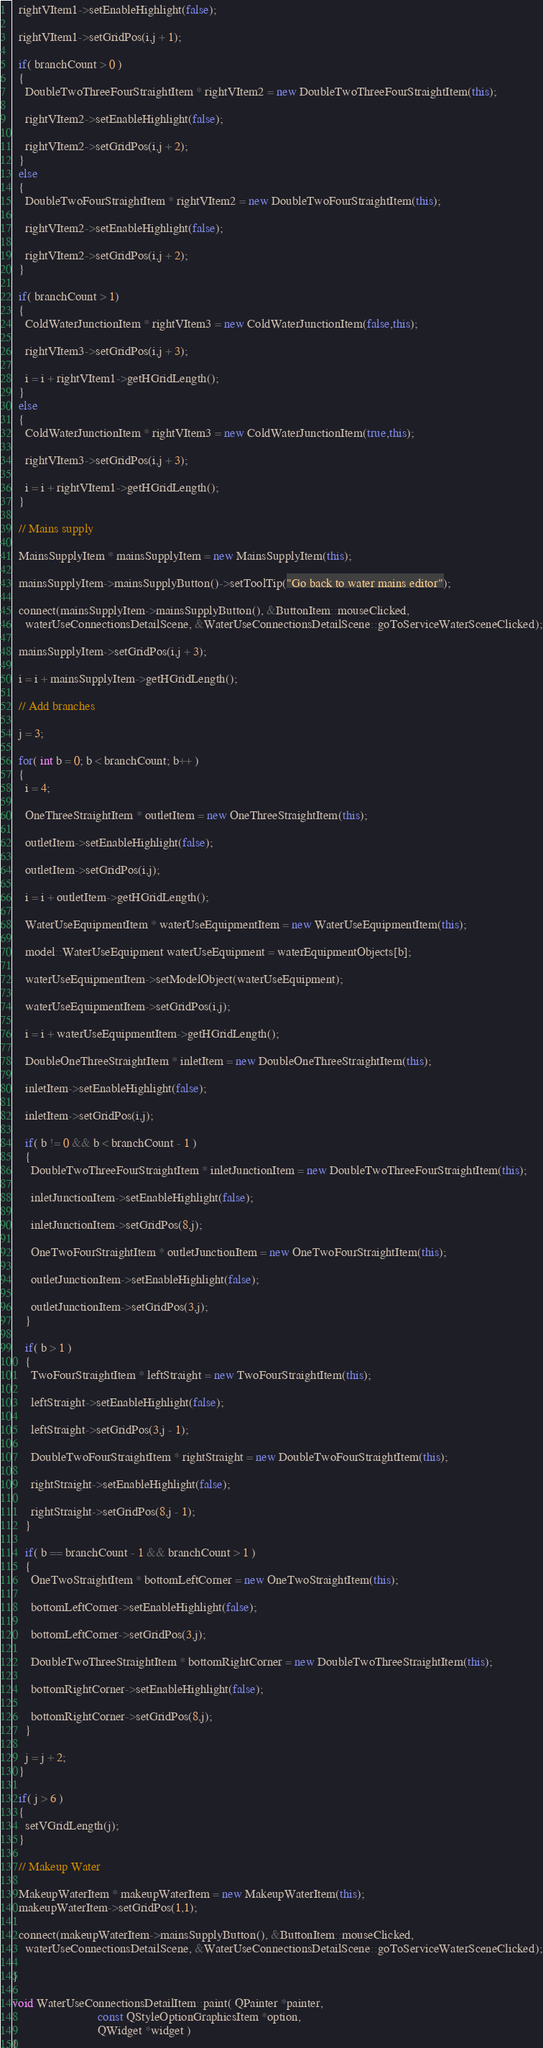<code> <loc_0><loc_0><loc_500><loc_500><_C++_>  rightVItem1->setEnableHighlight(false);

  rightVItem1->setGridPos(i,j + 1);

  if( branchCount > 0 )
  {
    DoubleTwoThreeFourStraightItem * rightVItem2 = new DoubleTwoThreeFourStraightItem(this);

    rightVItem2->setEnableHighlight(false);

    rightVItem2->setGridPos(i,j + 2);
  }
  else
  {
    DoubleTwoFourStraightItem * rightVItem2 = new DoubleTwoFourStraightItem(this);

    rightVItem2->setEnableHighlight(false);

    rightVItem2->setGridPos(i,j + 2);
  }

  if( branchCount > 1)
  {
    ColdWaterJunctionItem * rightVItem3 = new ColdWaterJunctionItem(false,this);

    rightVItem3->setGridPos(i,j + 3);

    i = i + rightVItem1->getHGridLength();
  }
  else
  {
    ColdWaterJunctionItem * rightVItem3 = new ColdWaterJunctionItem(true,this);

    rightVItem3->setGridPos(i,j + 3);

    i = i + rightVItem1->getHGridLength();
  }

  // Mains supply

  MainsSupplyItem * mainsSupplyItem = new MainsSupplyItem(this);

  mainsSupplyItem->mainsSupplyButton()->setToolTip("Go back to water mains editor");

  connect(mainsSupplyItem->mainsSupplyButton(), &ButtonItem::mouseClicked,
    waterUseConnectionsDetailScene, &WaterUseConnectionsDetailScene::goToServiceWaterSceneClicked);

  mainsSupplyItem->setGridPos(i,j + 3);

  i = i + mainsSupplyItem->getHGridLength();

  // Add branches

  j = 3;

  for( int b = 0; b < branchCount; b++ )
  {
    i = 4; 

    OneThreeStraightItem * outletItem = new OneThreeStraightItem(this);

    outletItem->setEnableHighlight(false);

    outletItem->setGridPos(i,j);

    i = i + outletItem->getHGridLength();

    WaterUseEquipmentItem * waterUseEquipmentItem = new WaterUseEquipmentItem(this);

    model::WaterUseEquipment waterUseEquipment = waterEquipmentObjects[b];

    waterUseEquipmentItem->setModelObject(waterUseEquipment);

    waterUseEquipmentItem->setGridPos(i,j);

    i = i + waterUseEquipmentItem->getHGridLength();

    DoubleOneThreeStraightItem * inletItem = new DoubleOneThreeStraightItem(this);

    inletItem->setEnableHighlight(false);

    inletItem->setGridPos(i,j);

    if( b != 0 && b < branchCount - 1 )
    {
      DoubleTwoThreeFourStraightItem * inletJunctionItem = new DoubleTwoThreeFourStraightItem(this);

      inletJunctionItem->setEnableHighlight(false);

      inletJunctionItem->setGridPos(8,j);

      OneTwoFourStraightItem * outletJunctionItem = new OneTwoFourStraightItem(this);

      outletJunctionItem->setEnableHighlight(false);

      outletJunctionItem->setGridPos(3,j);
    }

    if( b > 1 )
    {
      TwoFourStraightItem * leftStraight = new TwoFourStraightItem(this);

      leftStraight->setEnableHighlight(false);

      leftStraight->setGridPos(3,j - 1);

      DoubleTwoFourStraightItem * rightStraight = new DoubleTwoFourStraightItem(this);

      rightStraight->setEnableHighlight(false);

      rightStraight->setGridPos(8,j - 1);
    }

    if( b == branchCount - 1 && branchCount > 1 )
    {
      OneTwoStraightItem * bottomLeftCorner = new OneTwoStraightItem(this);

      bottomLeftCorner->setEnableHighlight(false);

      bottomLeftCorner->setGridPos(3,j);

      DoubleTwoThreeStraightItem * bottomRightCorner = new DoubleTwoThreeStraightItem(this);

      bottomRightCorner->setEnableHighlight(false);

      bottomRightCorner->setGridPos(8,j);
    }

    j = j + 2;
  }

  if( j > 6 )
  {
    setVGridLength(j);
  }

  // Makeup Water

  MakeupWaterItem * makeupWaterItem = new MakeupWaterItem(this);
  makeupWaterItem->setGridPos(1,1);

  connect(makeupWaterItem->mainsSupplyButton(), &ButtonItem::mouseClicked,
    waterUseConnectionsDetailScene, &WaterUseConnectionsDetailScene::goToServiceWaterSceneClicked);

}

void WaterUseConnectionsDetailItem::paint( QPainter *painter, 
                           const QStyleOptionGraphicsItem *option, 
                           QWidget *widget )
{</code> 